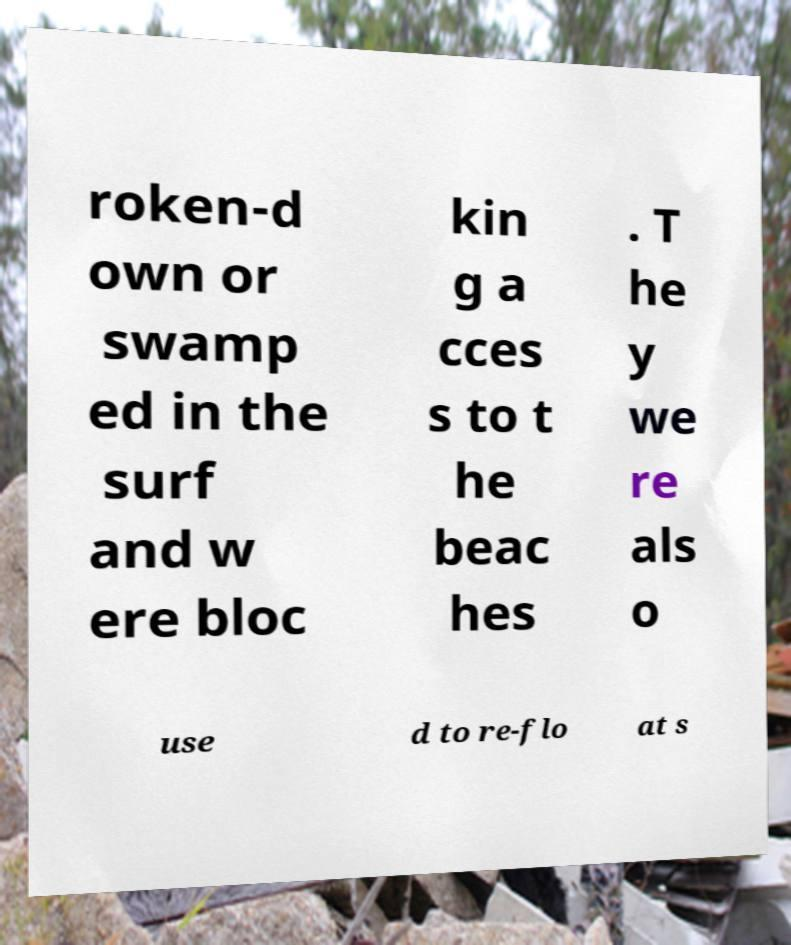Please read and relay the text visible in this image. What does it say? roken-d own or swamp ed in the surf and w ere bloc kin g a cces s to t he beac hes . T he y we re als o use d to re-flo at s 